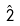<formula> <loc_0><loc_0><loc_500><loc_500>\hat { 2 }</formula> 